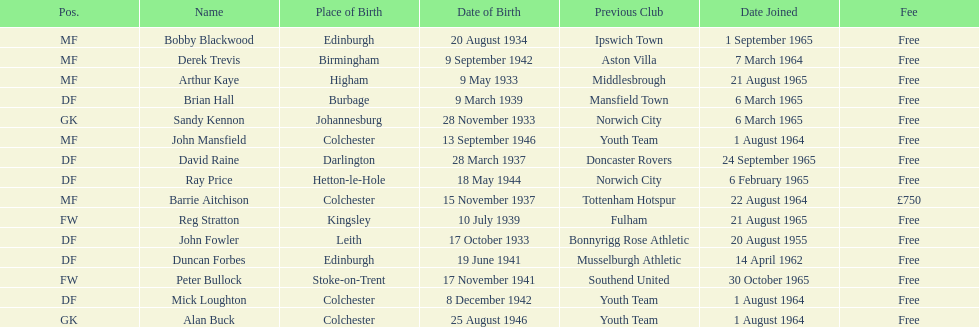What is the date of the lst player that joined? 20 August 1955. 